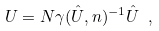Convert formula to latex. <formula><loc_0><loc_0><loc_500><loc_500>U = N \gamma ( \hat { U } , n ) ^ { - 1 } \hat { U } \ ,</formula> 